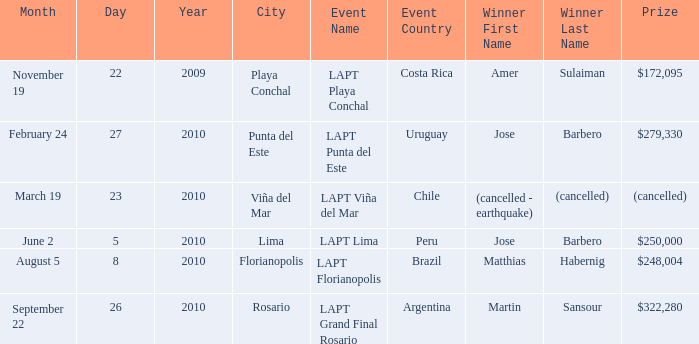What is the date of the event with a $322,280 prize? September 22–26, 2010. 